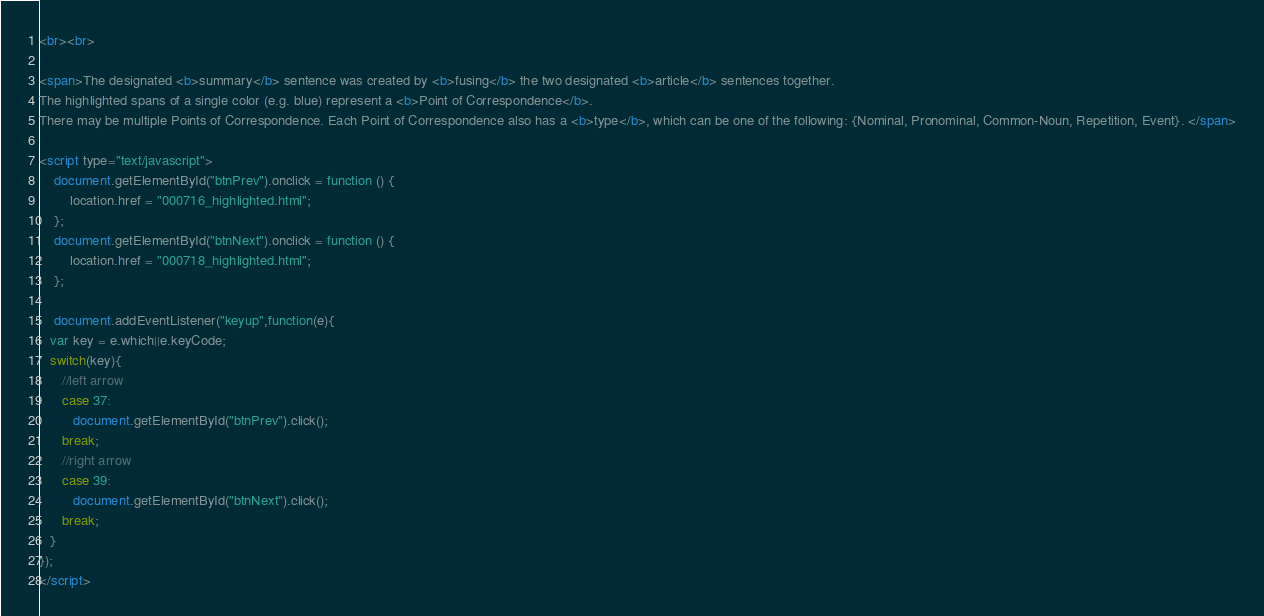<code> <loc_0><loc_0><loc_500><loc_500><_HTML_><br><br>

<span>The designated <b>summary</b> sentence was created by <b>fusing</b> the two designated <b>article</b> sentences together. 
The highlighted spans of a single color (e.g. blue) represent a <b>Point of Correspondence</b>. 
There may be multiple Points of Correspondence. Each Point of Correspondence also has a <b>type</b>, which can be one of the following: {Nominal, Pronominal, Common-Noun, Repetition, Event}. </span>

<script type="text/javascript">
    document.getElementById("btnPrev").onclick = function () {
        location.href = "000716_highlighted.html";
    };
    document.getElementById("btnNext").onclick = function () {
        location.href = "000718_highlighted.html";
    };

    document.addEventListener("keyup",function(e){
   var key = e.which||e.keyCode;
   switch(key){
      //left arrow
      case 37:
         document.getElementById("btnPrev").click();
      break;
      //right arrow
      case 39:
         document.getElementById("btnNext").click();
      break;
   }
});
</script>
</code> 